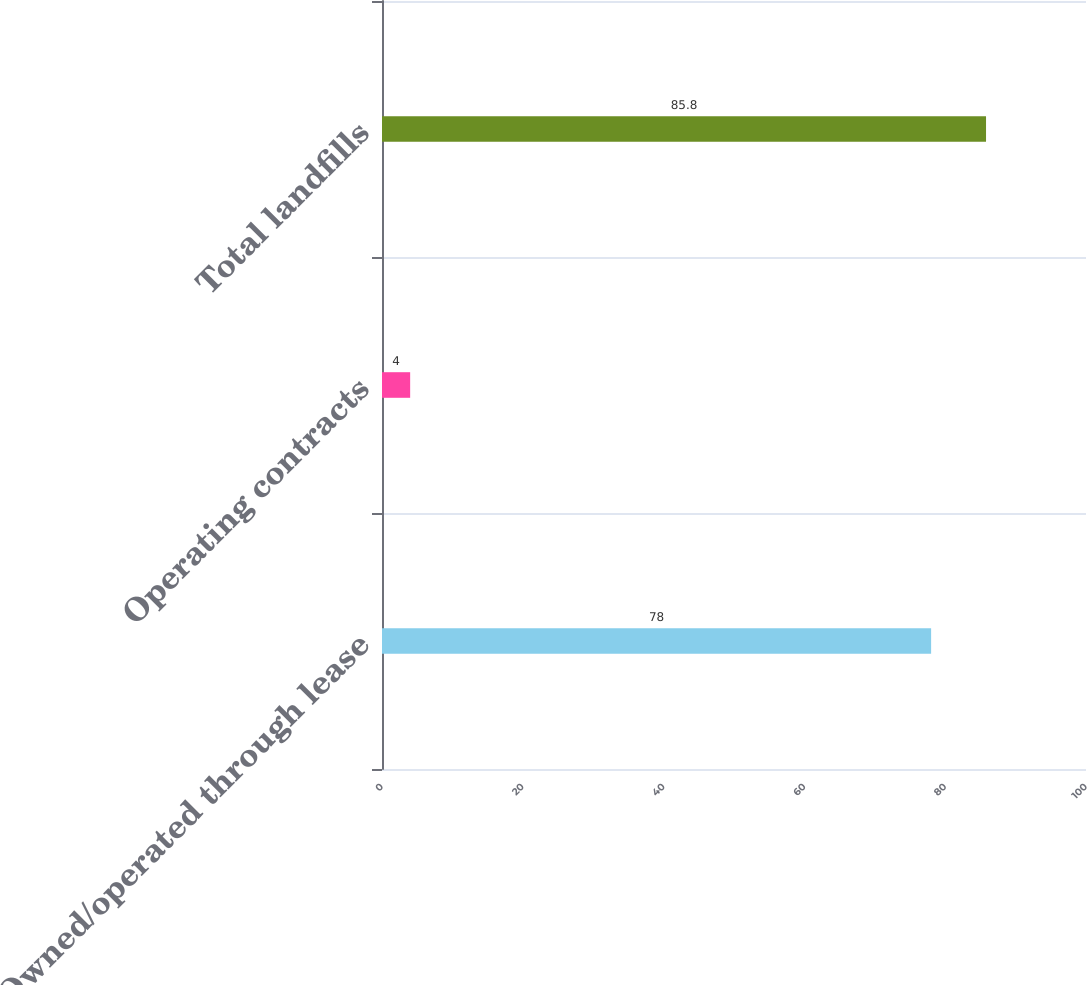Convert chart. <chart><loc_0><loc_0><loc_500><loc_500><bar_chart><fcel>Owned/operated through lease<fcel>Operating contracts<fcel>Total landfills<nl><fcel>78<fcel>4<fcel>85.8<nl></chart> 